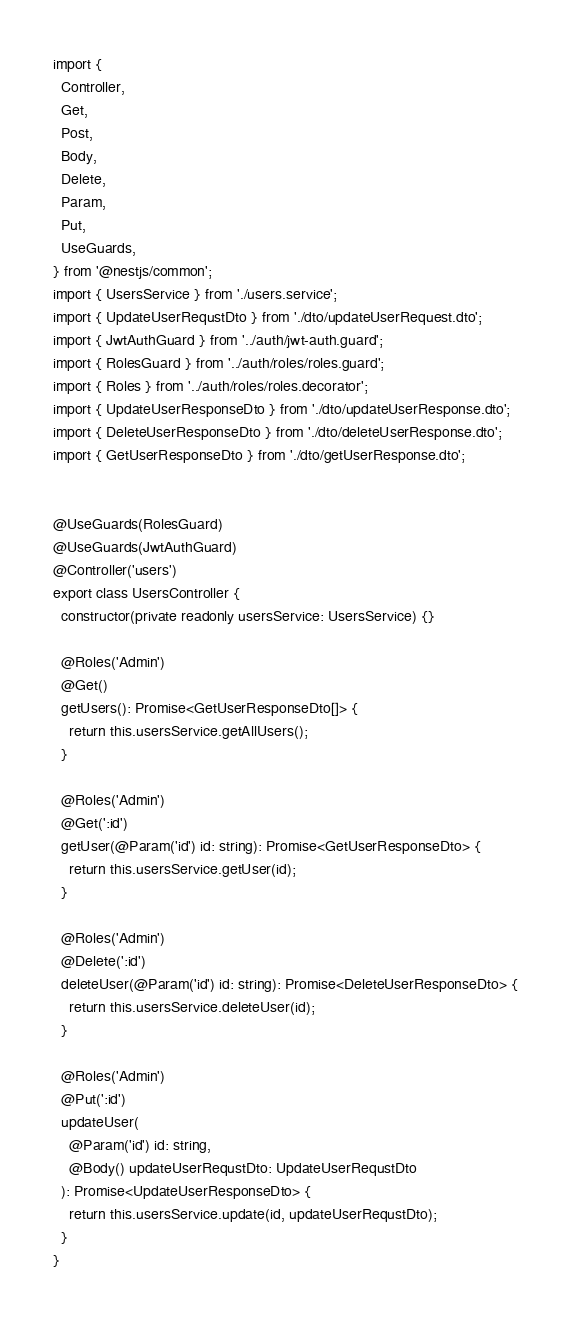Convert code to text. <code><loc_0><loc_0><loc_500><loc_500><_TypeScript_>import {
  Controller,
  Get,
  Post,
  Body,
  Delete,
  Param,
  Put,
  UseGuards,
} from '@nestjs/common';
import { UsersService } from './users.service';
import { UpdateUserRequstDto } from './dto/updateUserRequest.dto';
import { JwtAuthGuard } from '../auth/jwt-auth.guard';
import { RolesGuard } from '../auth/roles/roles.guard';
import { Roles } from '../auth/roles/roles.decorator';
import { UpdateUserResponseDto } from './dto/updateUserResponse.dto';
import { DeleteUserResponseDto } from './dto/deleteUserResponse.dto';
import { GetUserResponseDto } from './dto/getUserResponse.dto';


@UseGuards(RolesGuard)
@UseGuards(JwtAuthGuard)
@Controller('users')
export class UsersController {
  constructor(private readonly usersService: UsersService) {}

  @Roles('Admin')
  @Get()
  getUsers(): Promise<GetUserResponseDto[]> {        
    return this.usersService.getAllUsers();
  }

  @Roles('Admin')
  @Get(':id')
  getUser(@Param('id') id: string): Promise<GetUserResponseDto> {
    return this.usersService.getUser(id);
  }

  @Roles('Admin')
  @Delete(':id')
  deleteUser(@Param('id') id: string): Promise<DeleteUserResponseDto> {
    return this.usersService.deleteUser(id);
  }

  @Roles('Admin')
  @Put(':id')
  updateUser(
    @Param('id') id: string,
    @Body() updateUserRequstDto: UpdateUserRequstDto
  ): Promise<UpdateUserResponseDto> {
    return this.usersService.update(id, updateUserRequstDto);
  }
}
</code> 